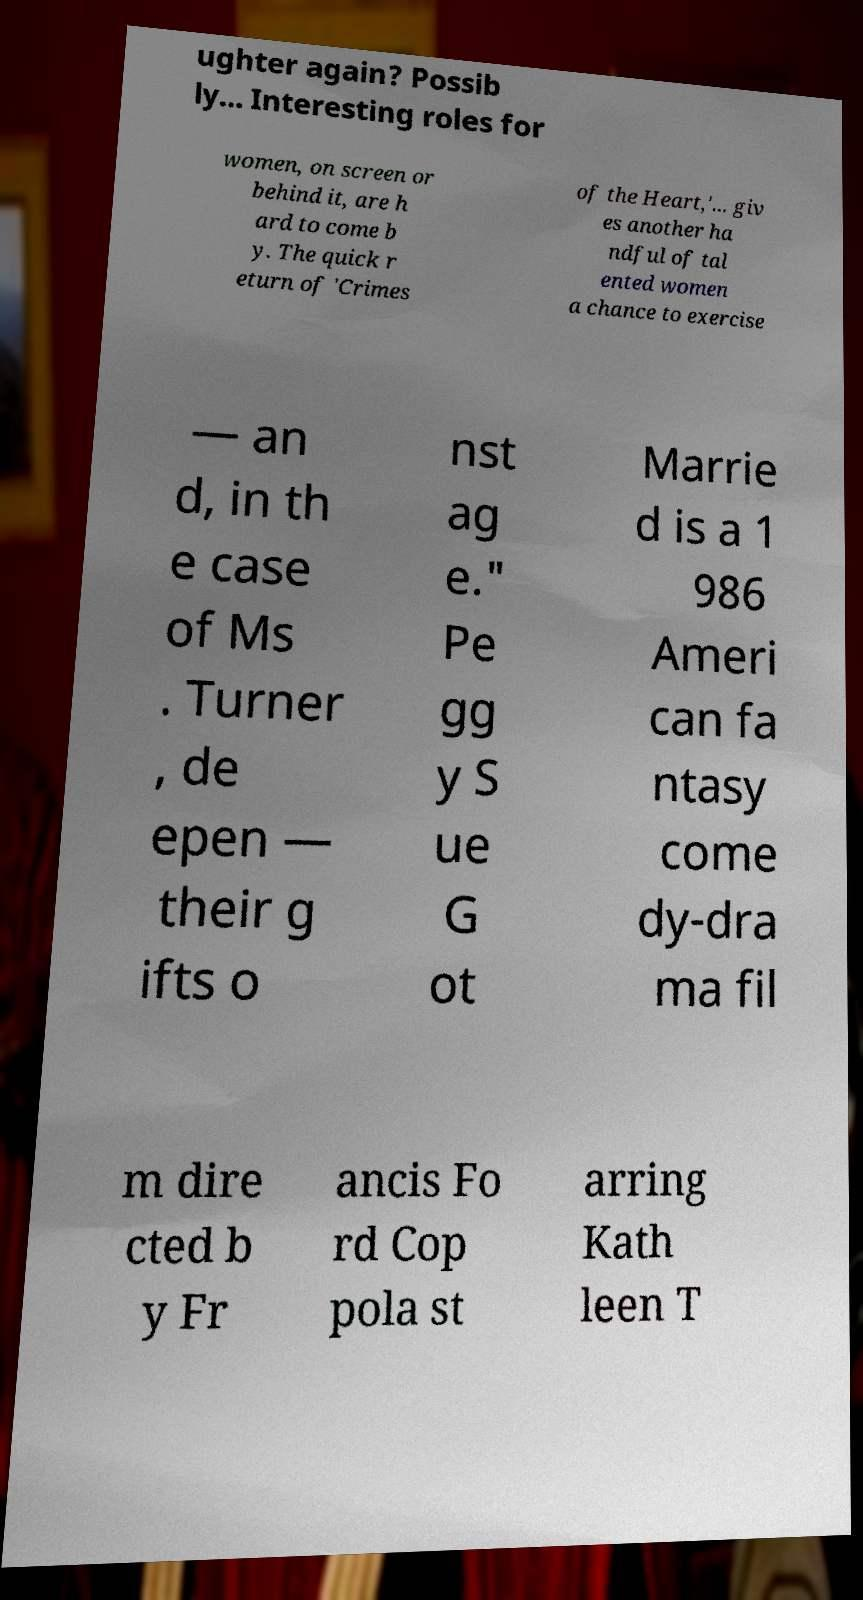Can you accurately transcribe the text from the provided image for me? ughter again? Possib ly... Interesting roles for women, on screen or behind it, are h ard to come b y. The quick r eturn of 'Crimes of the Heart,'... giv es another ha ndful of tal ented women a chance to exercise — an d, in th e case of Ms . Turner , de epen — their g ifts o nst ag e." Pe gg y S ue G ot Marrie d is a 1 986 Ameri can fa ntasy come dy-dra ma fil m dire cted b y Fr ancis Fo rd Cop pola st arring Kath leen T 